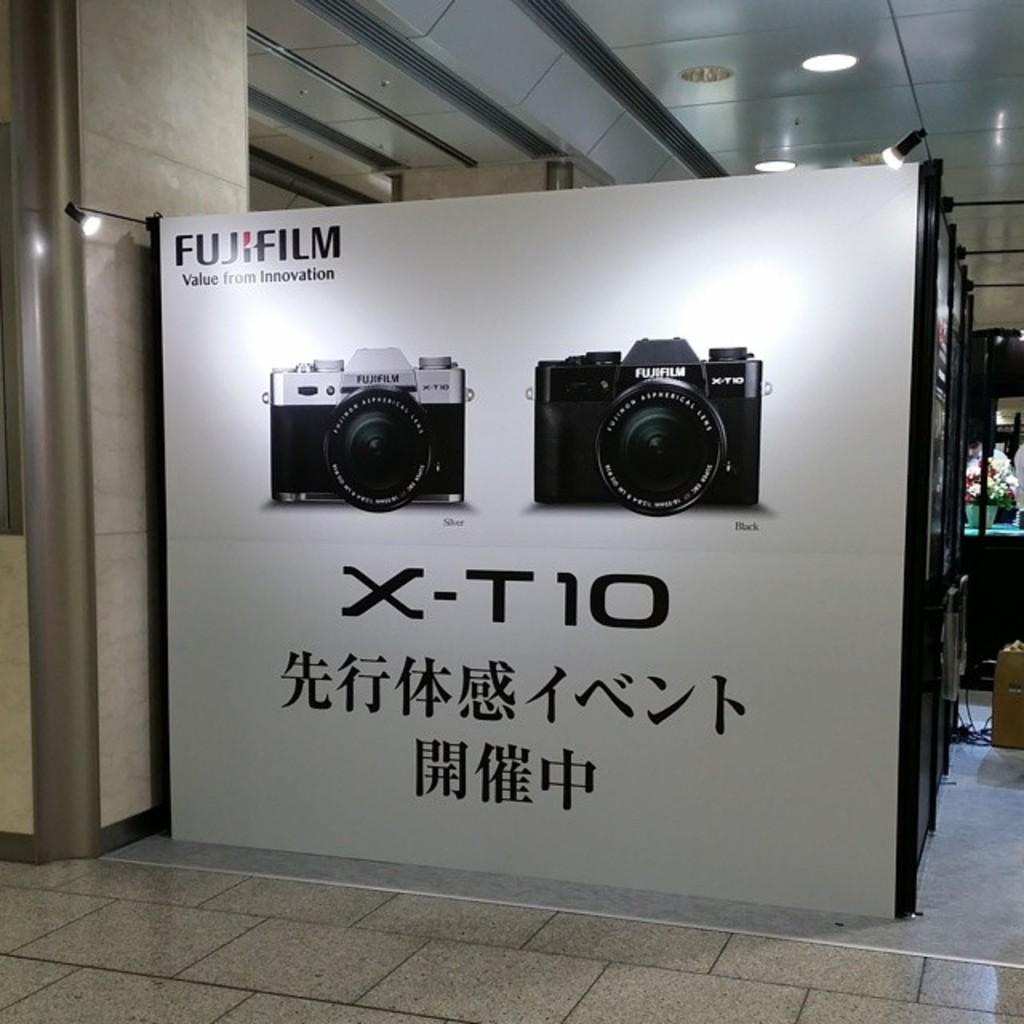What is the brand?
Offer a very short reply. Fujifilm. 